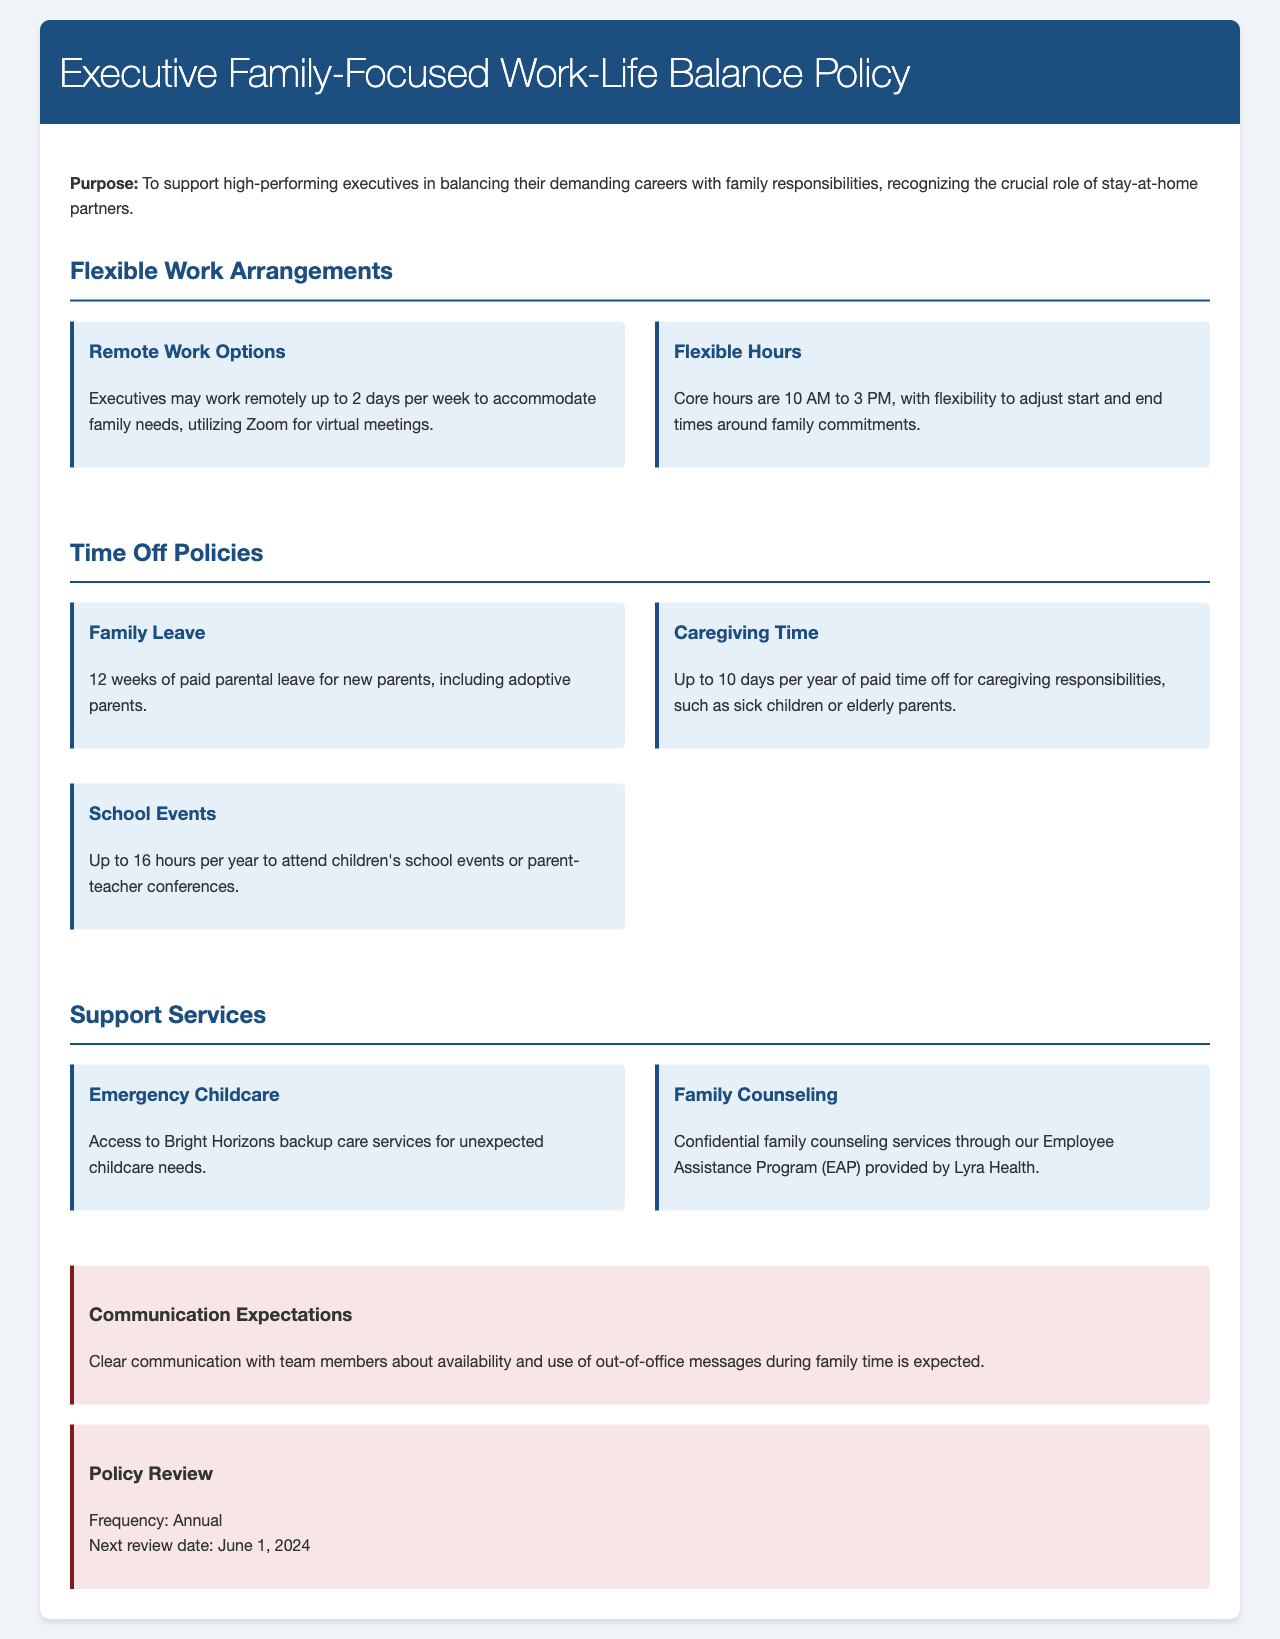What is the purpose of the policy? The purpose is to support high-performing executives in balancing their demanding careers with family responsibilities, recognizing the crucial role of stay-at-home partners.
Answer: To support high-performing executives in balancing their demanding careers with family responsibilities, recognizing the crucial role of stay-at-home partners How many remote work days are allowed per week? The document states that executives may work remotely up to 2 days per week to accommodate family needs.
Answer: 2 days What is the maximum paid parental leave offered? The document specifies that new parents, including adoptive parents, receive 12 weeks of paid parental leave.
Answer: 12 weeks How many days of paid time off for caregiving responsibilities can an executive take per year? The policy allows up to 10 days per year of paid time off for caregiving responsibilities, such as sick children or elderly parents.
Answer: 10 days What is the total number of hours allowed to attend children's school events? The document states that up to 16 hours per year is allowed to attend children's school events or parent-teacher conferences.
Answer: 16 hours What service is provided for unexpected childcare needs? The document mentions access to Bright Horizons backup care services for unexpected childcare needs.
Answer: Bright Horizons backup care services What is expected regarding team communication during family time? The policy states that clear communication with team members about availability and use of out-of-office messages during family time is expected.
Answer: Clear communication When is the next review date of the policy? The document specifies that the next review date is June 1, 2024.
Answer: June 1, 2024 What organization provides family counseling services? The document mentions that confidential family counseling services are provided through the Employee Assistance Program by Lyra Health.
Answer: Lyra Health 